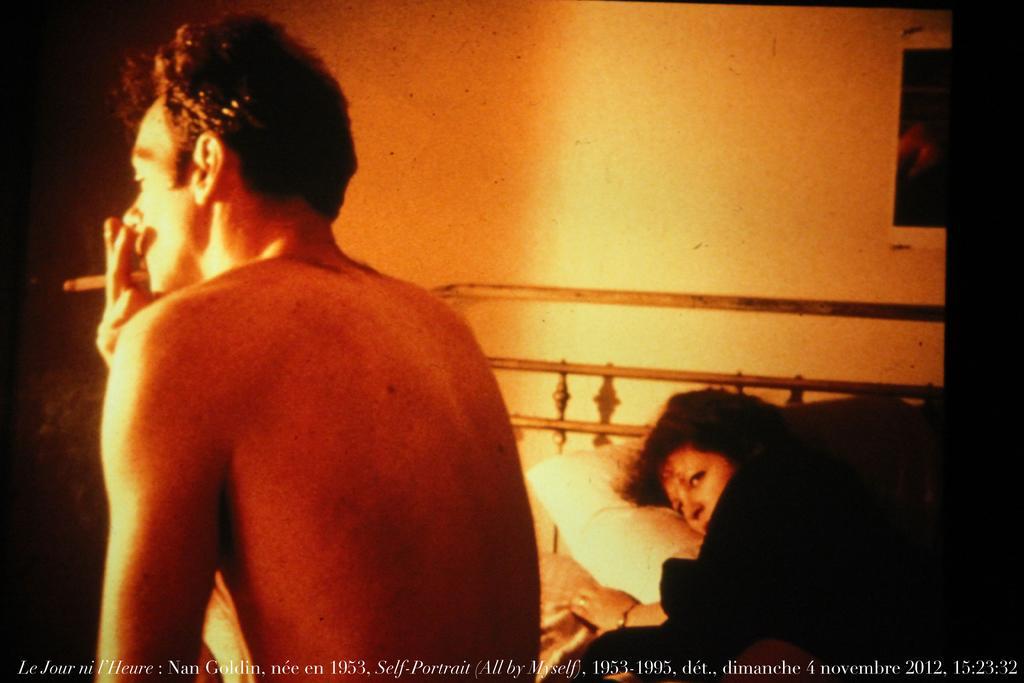Could you give a brief overview of what you see in this image? In this image I can see two persons. On the left side I can see one person is smoking and on the right side I can see one person is lying on the bed. On the bottom side of the image I can see a watermark and on the top right side I can see a poster on the wall. 